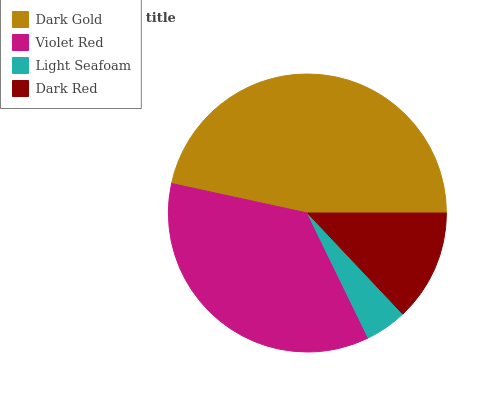Is Light Seafoam the minimum?
Answer yes or no. Yes. Is Dark Gold the maximum?
Answer yes or no. Yes. Is Violet Red the minimum?
Answer yes or no. No. Is Violet Red the maximum?
Answer yes or no. No. Is Dark Gold greater than Violet Red?
Answer yes or no. Yes. Is Violet Red less than Dark Gold?
Answer yes or no. Yes. Is Violet Red greater than Dark Gold?
Answer yes or no. No. Is Dark Gold less than Violet Red?
Answer yes or no. No. Is Violet Red the high median?
Answer yes or no. Yes. Is Dark Red the low median?
Answer yes or no. Yes. Is Light Seafoam the high median?
Answer yes or no. No. Is Violet Red the low median?
Answer yes or no. No. 